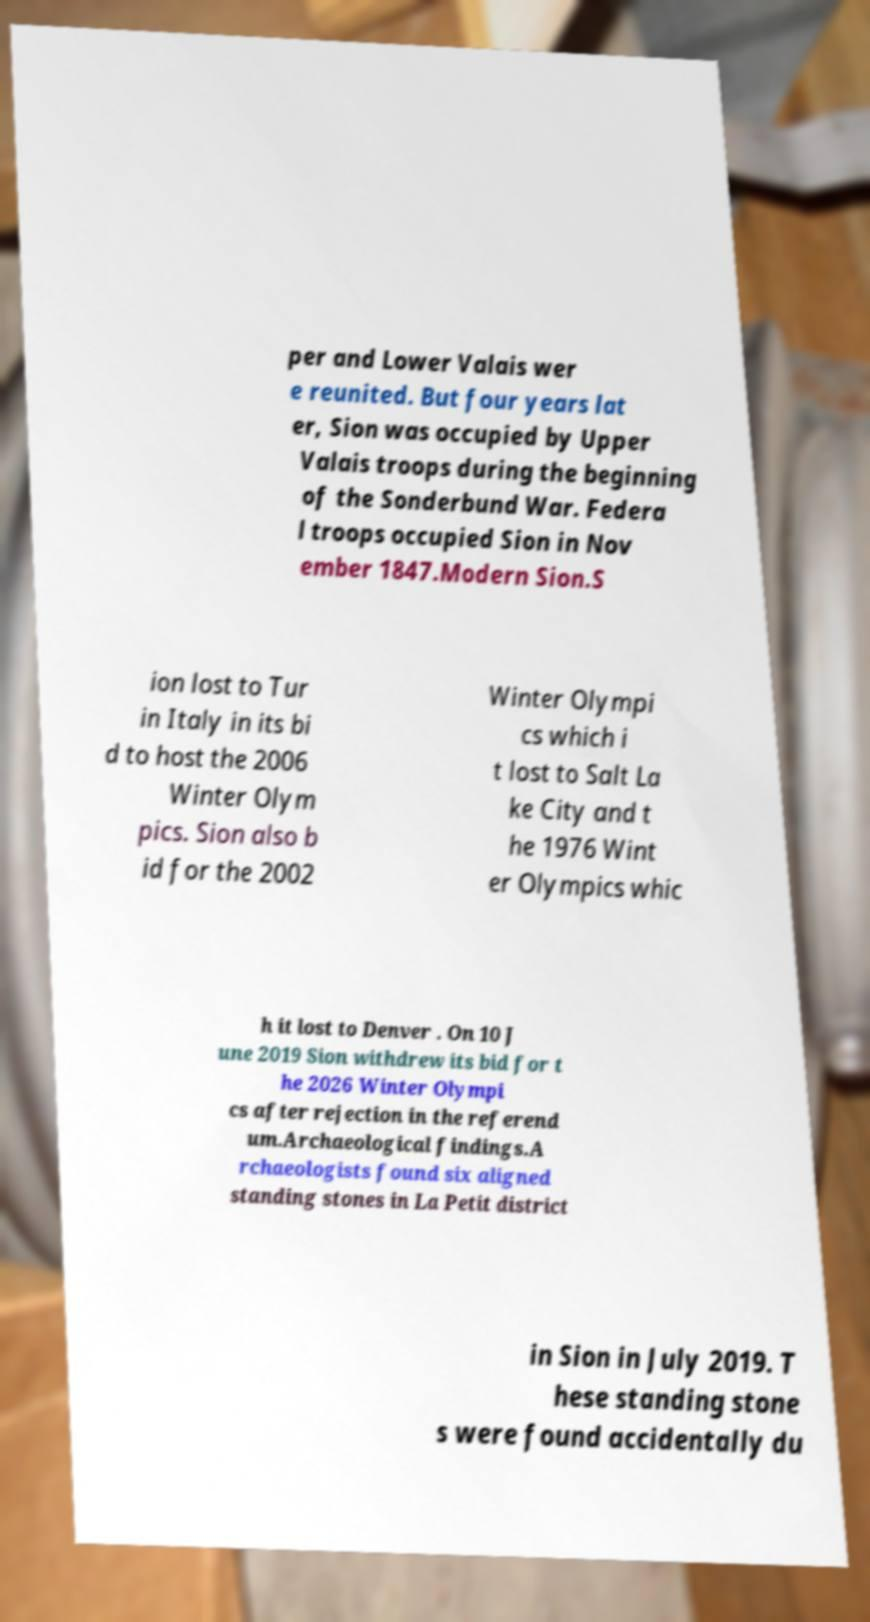What messages or text are displayed in this image? I need them in a readable, typed format. per and Lower Valais wer e reunited. But four years lat er, Sion was occupied by Upper Valais troops during the beginning of the Sonderbund War. Federa l troops occupied Sion in Nov ember 1847.Modern Sion.S ion lost to Tur in Italy in its bi d to host the 2006 Winter Olym pics. Sion also b id for the 2002 Winter Olympi cs which i t lost to Salt La ke City and t he 1976 Wint er Olympics whic h it lost to Denver . On 10 J une 2019 Sion withdrew its bid for t he 2026 Winter Olympi cs after rejection in the referend um.Archaeological findings.A rchaeologists found six aligned standing stones in La Petit district in Sion in July 2019. T hese standing stone s were found accidentally du 